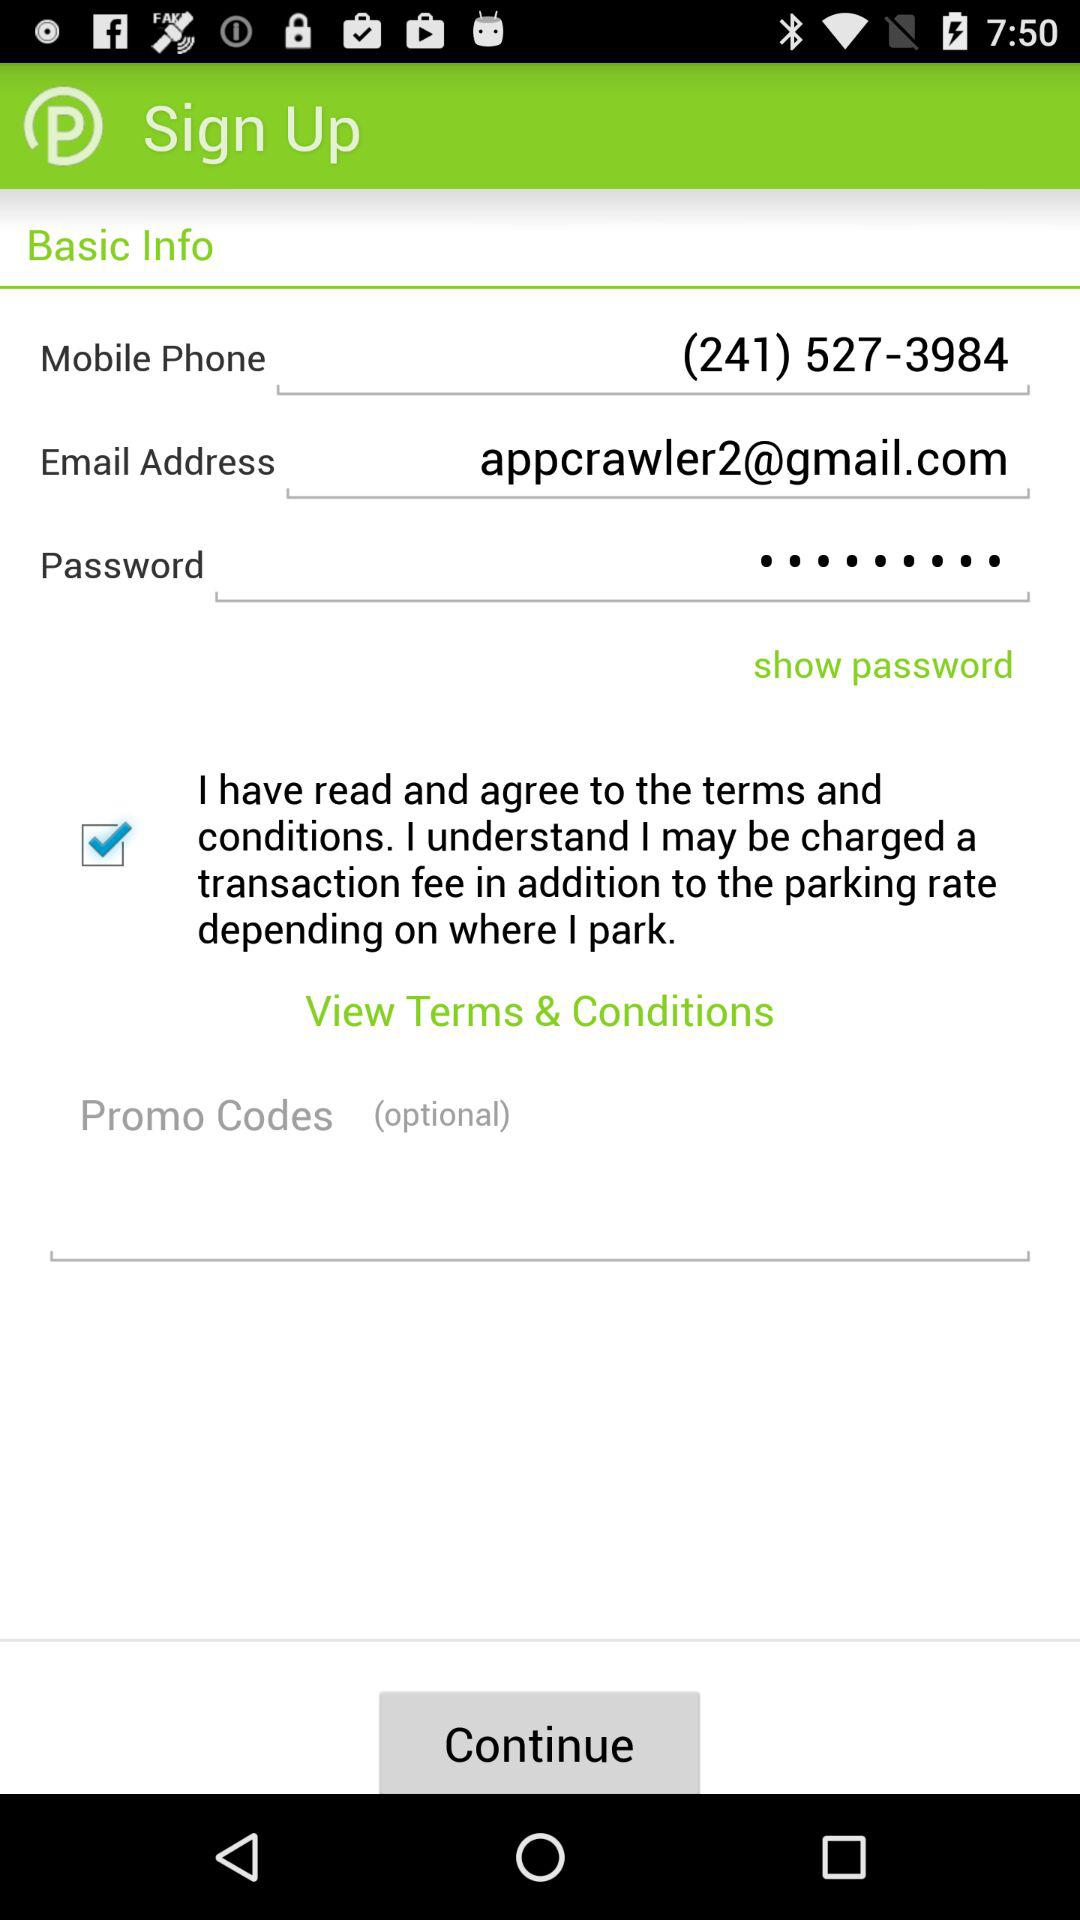What is the phone number? The phone number is (241) 527-3984. 